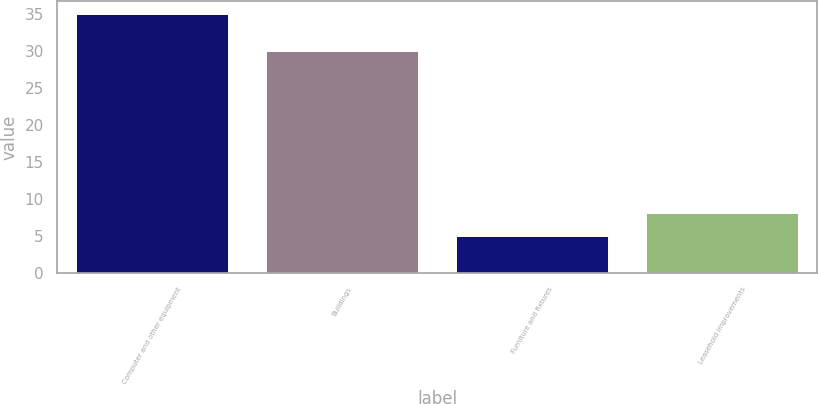<chart> <loc_0><loc_0><loc_500><loc_500><bar_chart><fcel>Computer and other equipment<fcel>Buildings<fcel>Furniture and fixtures<fcel>Leasehold improvements<nl><fcel>35<fcel>30<fcel>5<fcel>8<nl></chart> 